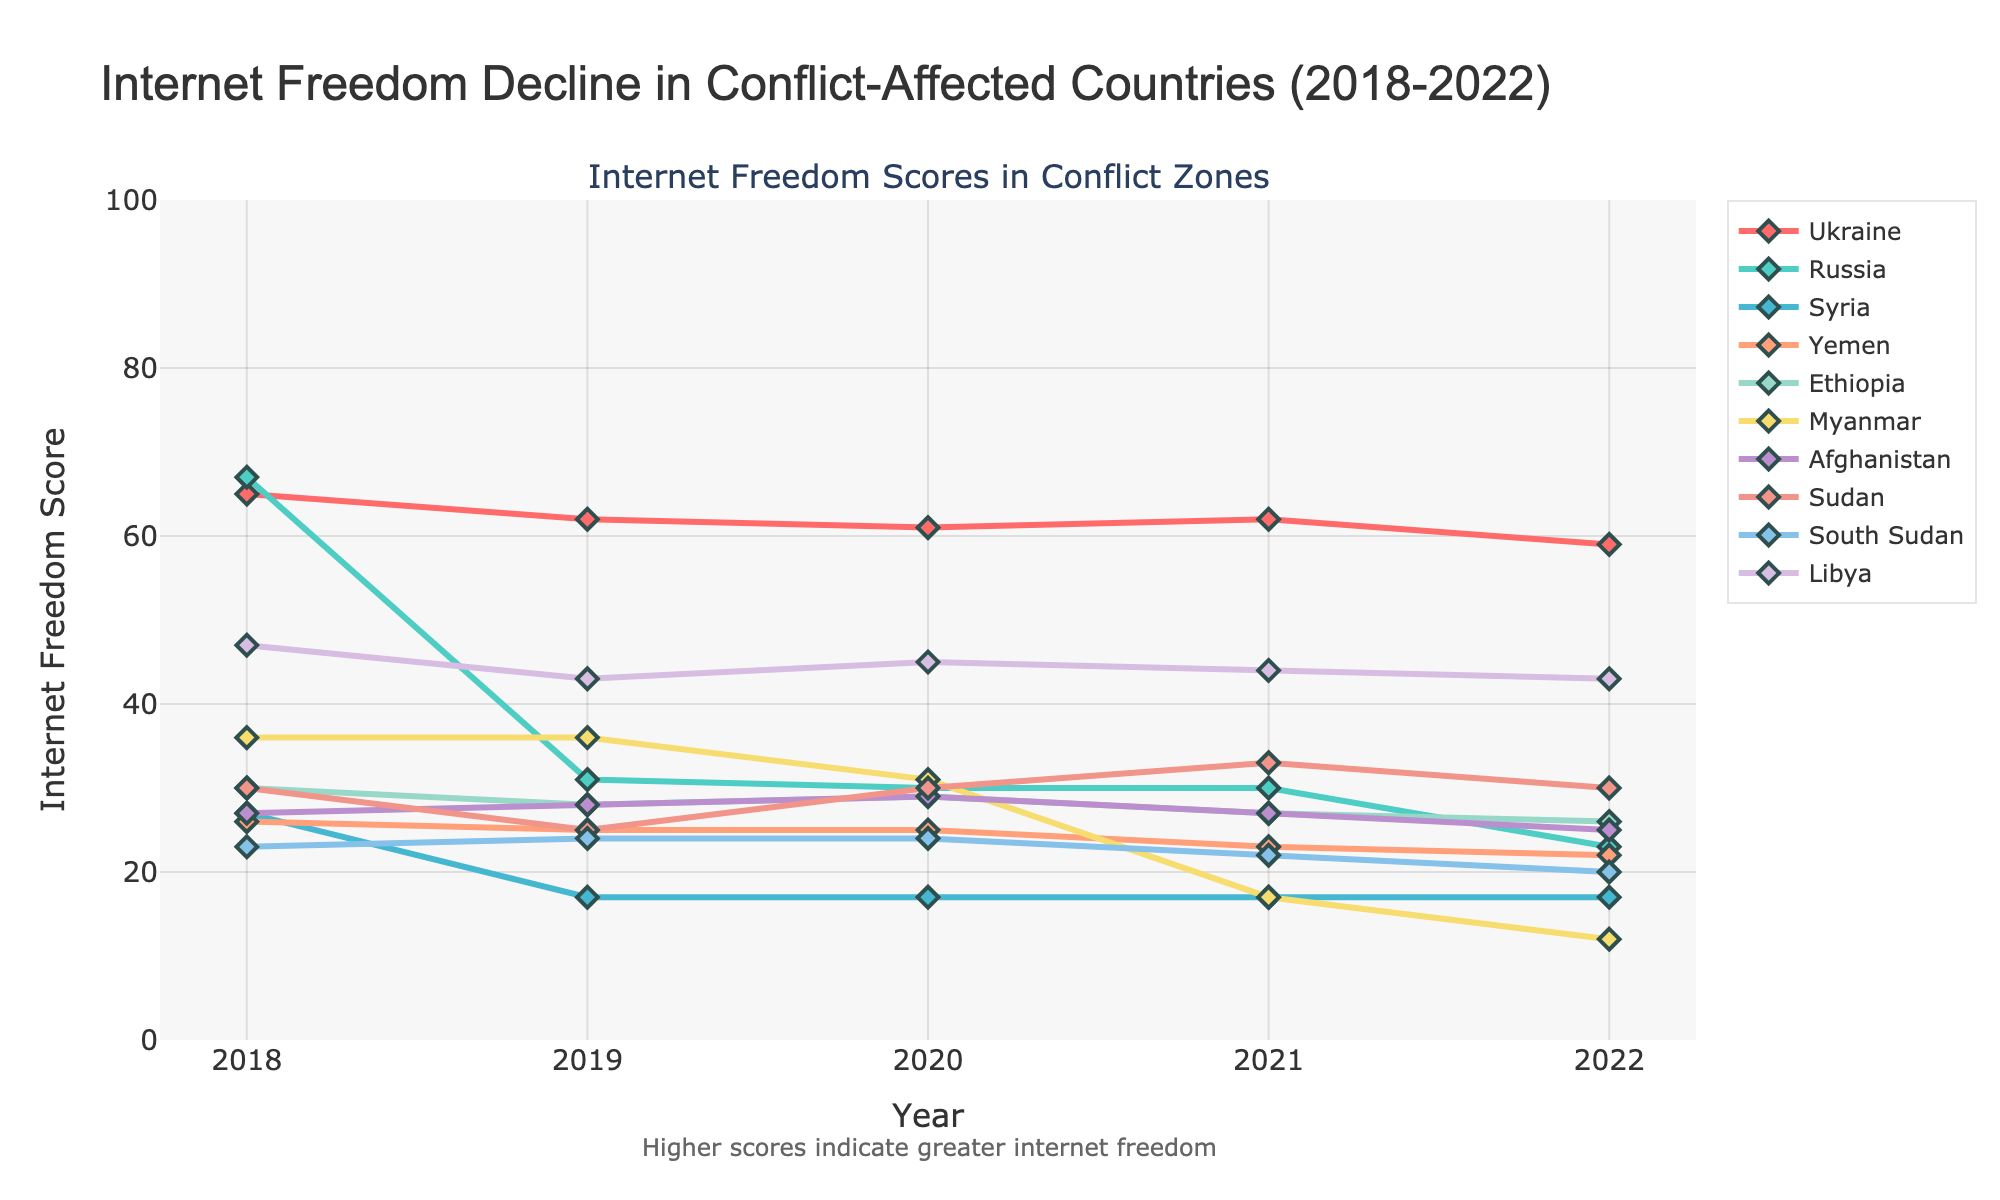Which country showed the greatest decline in internet freedom score between 2018 and 2022? First, note the scores for each year for all countries. Next, calculate the difference between 2018 and 2022 for each country. The greatest decline is the highest difference. For Russia, the decline is 67 - 23 = 44
Answer: Russia Which country had the highest internet freedom score in 2022? Look at the scores for 2022 for all countries and find the highest one. Ukraine has the highest score of 59
Answer: Ukraine What is the average internet freedom score for Yemen from 2018 to 2022? Sum the scores of Yemen from 2018 to 2022 (26 + 25 + 25 + 23 + 22) and divide by the number of years, which is 5. The sum is 121, and the average is 121/5 = 24.2
Answer: 24.2 Which year did Myanmar experience the largest drop in its internet freedom score? Look at the scores for Myanmar over the years and find the largest drop between consecutive years. The largest drop is from 31 in 2020 to 17 in 2021, which is a drop of 14 points
Answer: 2021 Which two countries had no change in their internet freedom scores from 2019 to 2020? Compare the scores for 2019 and 2020 for all countries. Syria (17 to 17) and Libya (43 to 45) had no change in their scores
Answer: Syria and Libya Between Ethiopia and Sudan, which country had a higher internet freedom score in 2021? Compare the scores for Ethiopia and Sudan in 2021. Ethiopia had a score of 27, while Sudan had a higher score of 33
Answer: Sudan How many countries had a lower internet freedom score in 2022 compared to 2019? Compare the scores for all countries from 2022 and 2019. The countries with lower scores in 2022 are Ukraine, Russia, Yemen, Ethiopia, Myanmar, Afghanistan, South Sudan, and Libya. The number of countries is 8
Answer: 8 What was the difference in internet freedom score for Ethiopia between 2018 and 2021? Subtract the 2021 score from the 2018 score for Ethiopia. The scores are 30 in 2018 and 27 in 2021, so the difference is 30 - 27 = 3
Answer: 3 